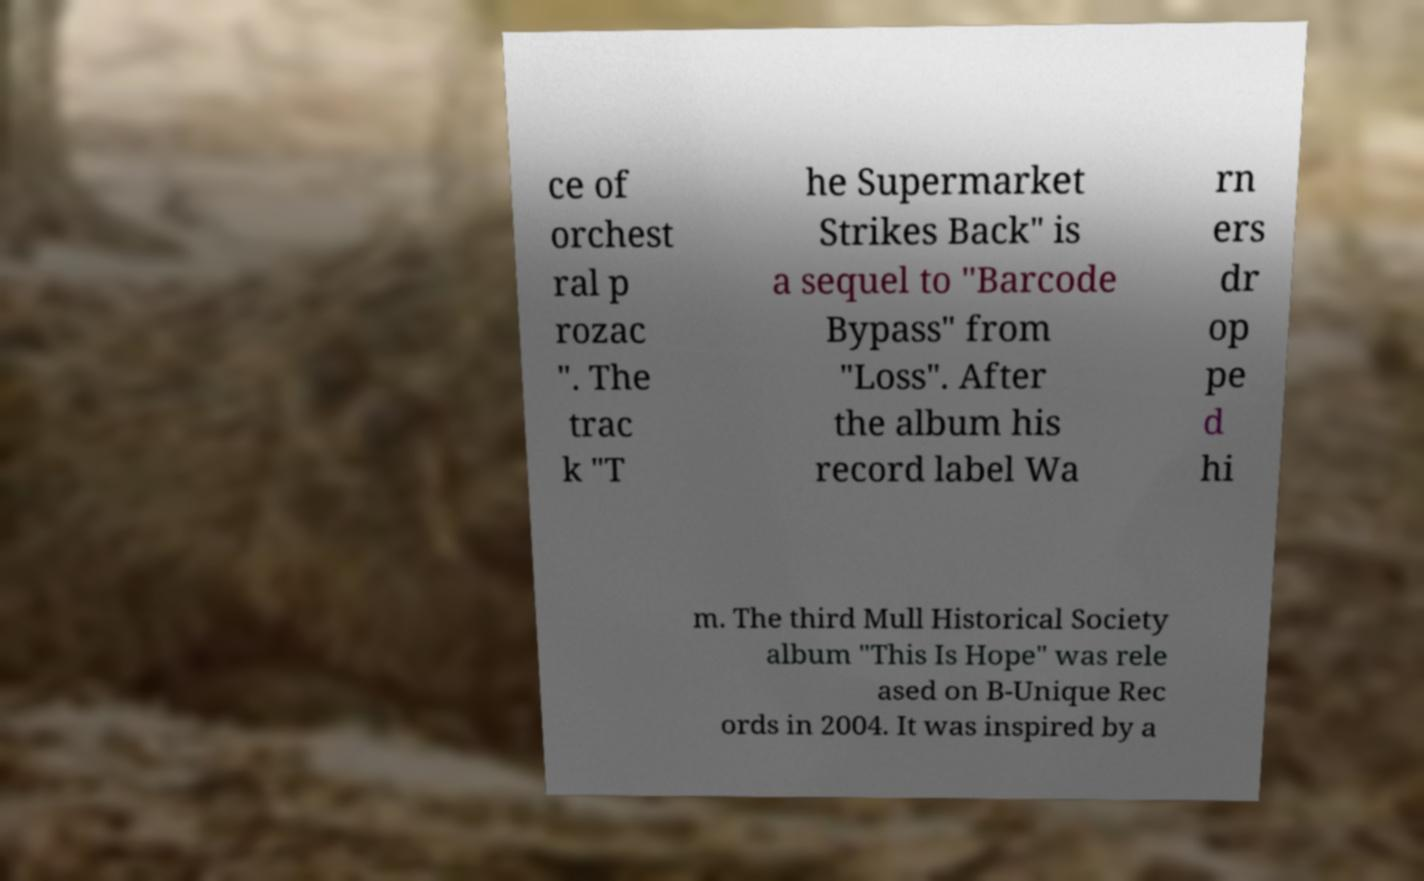Please read and relay the text visible in this image. What does it say? ce of orchest ral p rozac ". The trac k "T he Supermarket Strikes Back" is a sequel to "Barcode Bypass" from "Loss". After the album his record label Wa rn ers dr op pe d hi m. The third Mull Historical Society album "This Is Hope" was rele ased on B-Unique Rec ords in 2004. It was inspired by a 